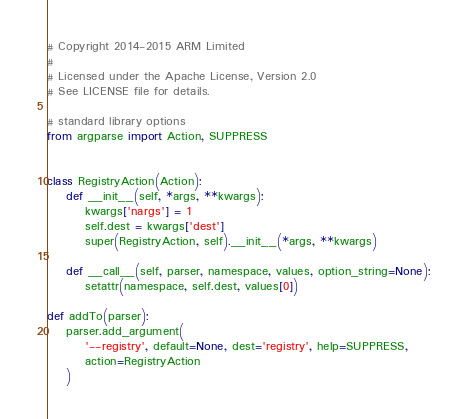<code> <loc_0><loc_0><loc_500><loc_500><_Python_># Copyright 2014-2015 ARM Limited
#
# Licensed under the Apache License, Version 2.0
# See LICENSE file for details.

# standard library options
from argparse import Action, SUPPRESS


class RegistryAction(Action):
    def __init__(self, *args, **kwargs):
        kwargs['nargs'] = 1
        self.dest = kwargs['dest']
        super(RegistryAction, self).__init__(*args, **kwargs)

    def __call__(self, parser, namespace, values, option_string=None):
        setattr(namespace, self.dest, values[0])

def addTo(parser):
    parser.add_argument(
        '--registry', default=None, dest='registry', help=SUPPRESS,
        action=RegistryAction
    )
</code> 